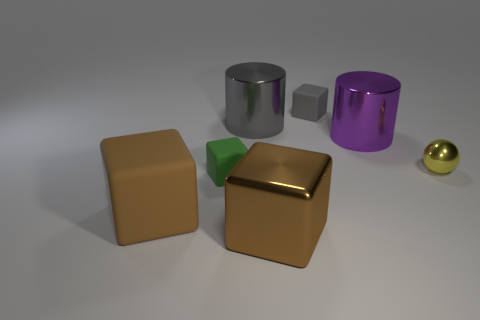Add 2 tiny cyan objects. How many objects exist? 9 Subtract all gray blocks. How many blocks are left? 3 Subtract all brown blocks. How many blocks are left? 2 Subtract 0 brown cylinders. How many objects are left? 7 Subtract all cylinders. How many objects are left? 5 Subtract 1 cubes. How many cubes are left? 3 Subtract all purple spheres. Subtract all gray cylinders. How many spheres are left? 1 Subtract all blue balls. How many brown blocks are left? 2 Subtract all small gray matte blocks. Subtract all big cyan metal cylinders. How many objects are left? 6 Add 4 small cubes. How many small cubes are left? 6 